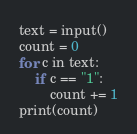<code> <loc_0><loc_0><loc_500><loc_500><_Python_>text = input()
count = 0
for c in text:
    if c == "1":
        count += 1
print(count)
</code> 